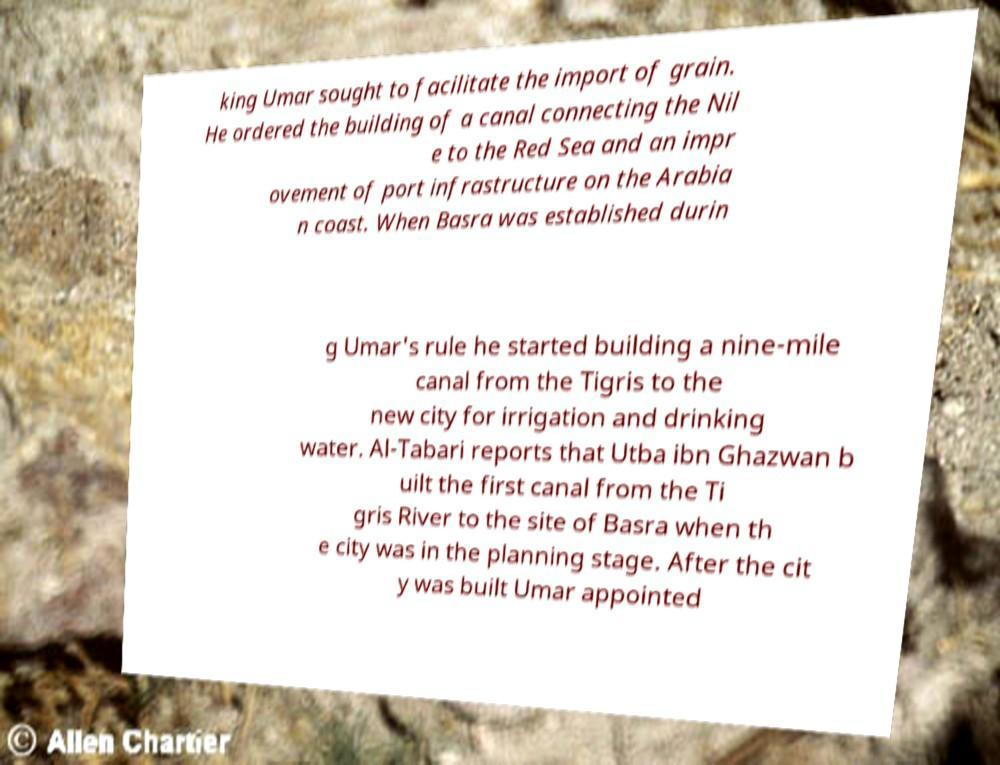What messages or text are displayed in this image? I need them in a readable, typed format. king Umar sought to facilitate the import of grain. He ordered the building of a canal connecting the Nil e to the Red Sea and an impr ovement of port infrastructure on the Arabia n coast. When Basra was established durin g Umar's rule he started building a nine-mile canal from the Tigris to the new city for irrigation and drinking water. Al-Tabari reports that Utba ibn Ghazwan b uilt the first canal from the Ti gris River to the site of Basra when th e city was in the planning stage. After the cit y was built Umar appointed 